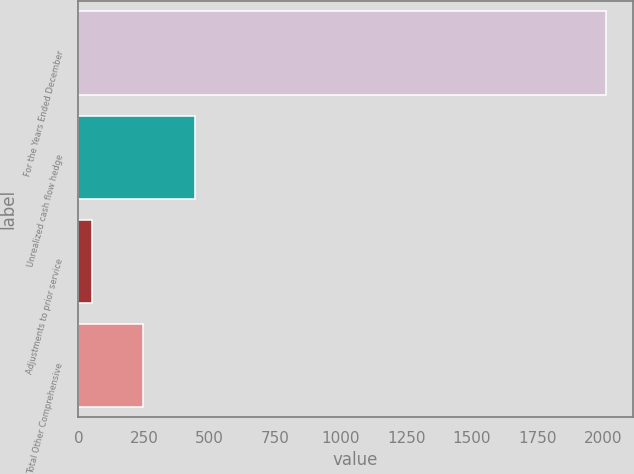<chart> <loc_0><loc_0><loc_500><loc_500><bar_chart><fcel>For the Years Ended December<fcel>Unrealized cash flow hedge<fcel>Adjustments to prior service<fcel>Total Other Comprehensive<nl><fcel>2013<fcel>442.84<fcel>50.3<fcel>246.57<nl></chart> 